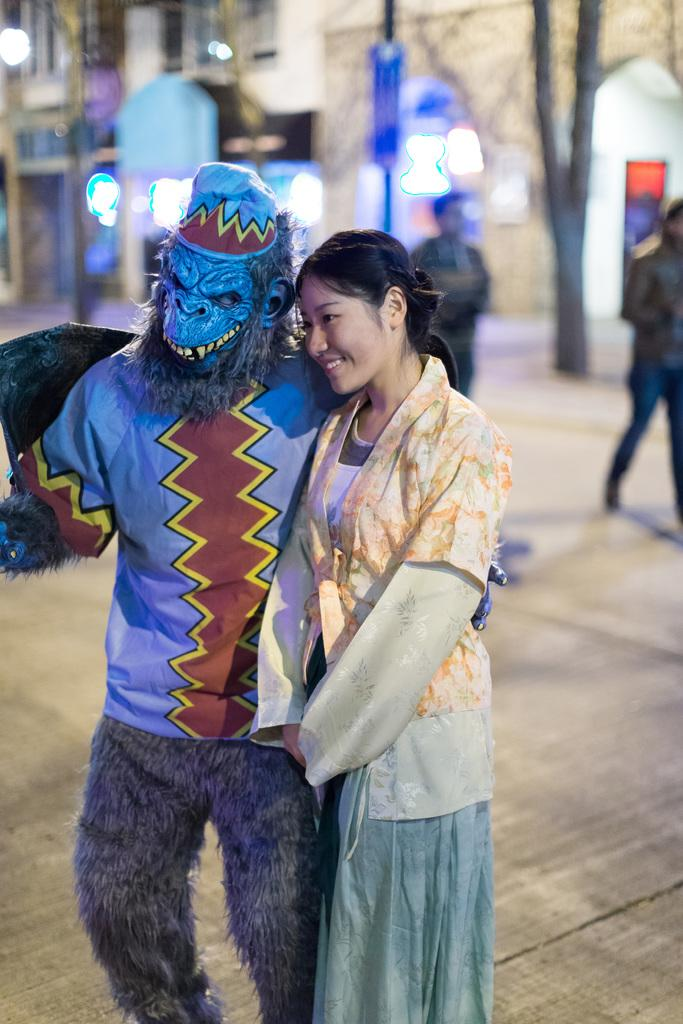What is the man in the image wearing on his face? The man is wearing a mask in the image. Where is the man located in the image? The man is in the center of the image. What is the woman in the image doing? The woman is standing on the ground in the image. What can be seen in the background of the image? There are lights, persons, trees, and a building in the background of the image. What type of curtain is hanging from the man's arm in the image? There is no curtain present in the image; the man is wearing a mask. What color is the pin on the woman's skin in the image? There is no pin or mention of the woman's skin color in the image; she is simply standing on the ground. 